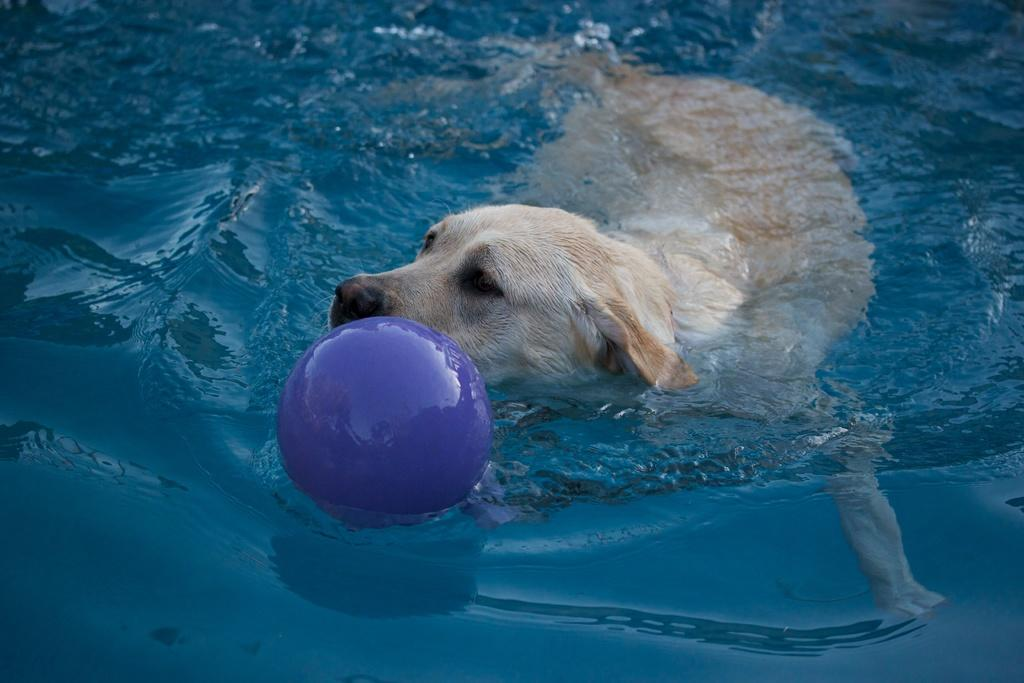What type of animal is in the image? There is a brown color Labrador dog in the image. What is the dog doing in the image? The dog is swimming in the water. What other object can be seen in the image? There is a blue color ball in the image. What type of snow can be seen falling in the image? There is no snow present in the image; it features a dog swimming in the water and a blue ball. What type of shop can be seen in the background of the image? There is no shop present in the image; it features a dog swimming in the water and a blue ball. 